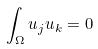<formula> <loc_0><loc_0><loc_500><loc_500>\int _ { \Omega } u _ { j } u _ { k } = 0</formula> 